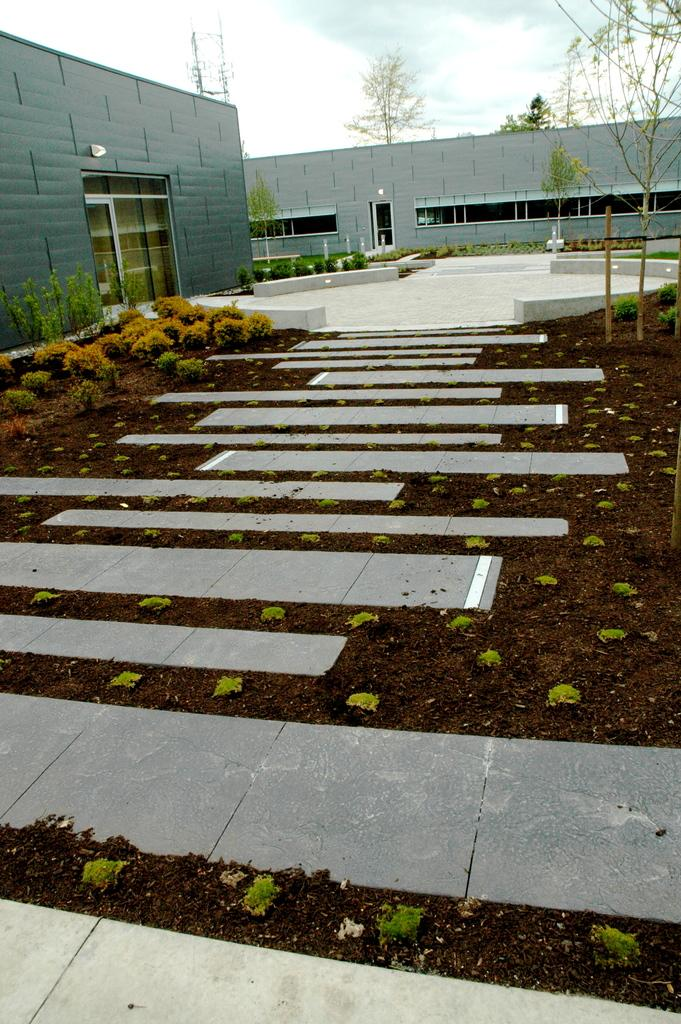What is the main subject in the center of the image? There is a way in the center of the image. What type of vegetation can be seen in the image? There are plants and trees in the image. What kind of structures are visible in the image? There appear to be walls in the image. What type of jeans is the person wearing in the image? There is no person wearing jeans in the image. How does the way in the image make people shake? The way in the image does not cause people to shake; it is a path or road. 